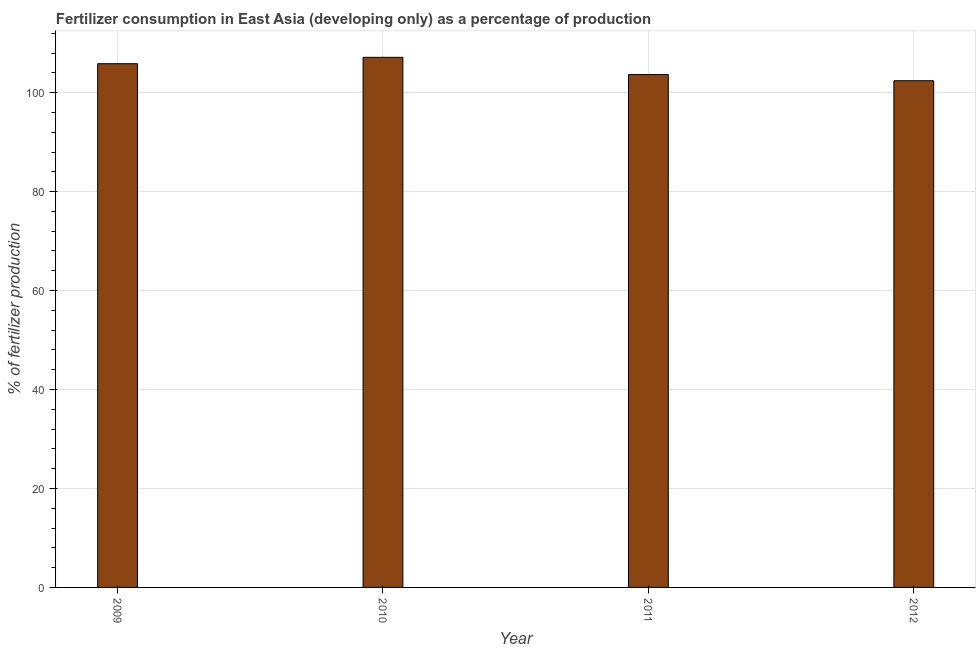Does the graph contain grids?
Offer a very short reply. Yes. What is the title of the graph?
Your response must be concise. Fertilizer consumption in East Asia (developing only) as a percentage of production. What is the label or title of the Y-axis?
Provide a succinct answer. % of fertilizer production. What is the amount of fertilizer consumption in 2010?
Ensure brevity in your answer.  107.14. Across all years, what is the maximum amount of fertilizer consumption?
Give a very brief answer. 107.14. Across all years, what is the minimum amount of fertilizer consumption?
Provide a succinct answer. 102.41. In which year was the amount of fertilizer consumption maximum?
Offer a very short reply. 2010. In which year was the amount of fertilizer consumption minimum?
Ensure brevity in your answer.  2012. What is the sum of the amount of fertilizer consumption?
Your answer should be compact. 419.06. What is the difference between the amount of fertilizer consumption in 2010 and 2011?
Keep it short and to the point. 3.49. What is the average amount of fertilizer consumption per year?
Provide a short and direct response. 104.77. What is the median amount of fertilizer consumption?
Your response must be concise. 104.75. In how many years, is the amount of fertilizer consumption greater than 48 %?
Offer a very short reply. 4. Do a majority of the years between 2009 and 2010 (inclusive) have amount of fertilizer consumption greater than 76 %?
Your answer should be compact. Yes. What is the ratio of the amount of fertilizer consumption in 2010 to that in 2011?
Offer a terse response. 1.03. Is the amount of fertilizer consumption in 2009 less than that in 2011?
Give a very brief answer. No. What is the difference between the highest and the second highest amount of fertilizer consumption?
Ensure brevity in your answer.  1.29. What is the difference between the highest and the lowest amount of fertilizer consumption?
Provide a short and direct response. 4.73. How many bars are there?
Make the answer very short. 4. Are all the bars in the graph horizontal?
Offer a terse response. No. What is the difference between two consecutive major ticks on the Y-axis?
Your answer should be very brief. 20. Are the values on the major ticks of Y-axis written in scientific E-notation?
Offer a terse response. No. What is the % of fertilizer production in 2009?
Provide a succinct answer. 105.86. What is the % of fertilizer production in 2010?
Offer a very short reply. 107.14. What is the % of fertilizer production in 2011?
Your answer should be compact. 103.65. What is the % of fertilizer production in 2012?
Provide a succinct answer. 102.41. What is the difference between the % of fertilizer production in 2009 and 2010?
Provide a short and direct response. -1.29. What is the difference between the % of fertilizer production in 2009 and 2011?
Make the answer very short. 2.2. What is the difference between the % of fertilizer production in 2009 and 2012?
Offer a very short reply. 3.44. What is the difference between the % of fertilizer production in 2010 and 2011?
Keep it short and to the point. 3.49. What is the difference between the % of fertilizer production in 2010 and 2012?
Offer a terse response. 4.73. What is the difference between the % of fertilizer production in 2011 and 2012?
Make the answer very short. 1.24. What is the ratio of the % of fertilizer production in 2009 to that in 2010?
Your answer should be compact. 0.99. What is the ratio of the % of fertilizer production in 2009 to that in 2011?
Ensure brevity in your answer.  1.02. What is the ratio of the % of fertilizer production in 2009 to that in 2012?
Provide a short and direct response. 1.03. What is the ratio of the % of fertilizer production in 2010 to that in 2011?
Give a very brief answer. 1.03. What is the ratio of the % of fertilizer production in 2010 to that in 2012?
Offer a terse response. 1.05. 